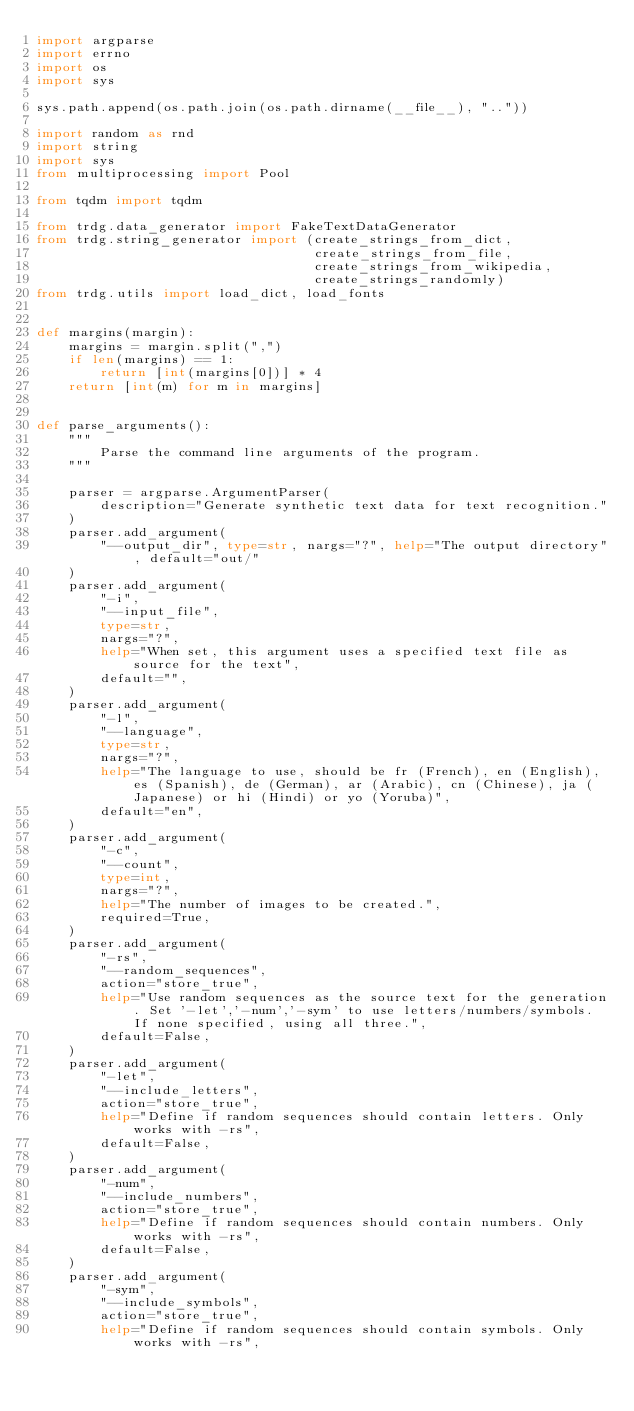Convert code to text. <code><loc_0><loc_0><loc_500><loc_500><_Python_>import argparse
import errno
import os
import sys

sys.path.append(os.path.join(os.path.dirname(__file__), ".."))

import random as rnd
import string
import sys
from multiprocessing import Pool

from tqdm import tqdm

from trdg.data_generator import FakeTextDataGenerator
from trdg.string_generator import (create_strings_from_dict,
                                   create_strings_from_file,
                                   create_strings_from_wikipedia,
                                   create_strings_randomly)
from trdg.utils import load_dict, load_fonts


def margins(margin):
    margins = margin.split(",")
    if len(margins) == 1:
        return [int(margins[0])] * 4
    return [int(m) for m in margins]


def parse_arguments():
    """
        Parse the command line arguments of the program.
    """

    parser = argparse.ArgumentParser(
        description="Generate synthetic text data for text recognition."
    )
    parser.add_argument(
        "--output_dir", type=str, nargs="?", help="The output directory", default="out/"
    )
    parser.add_argument(
        "-i",
        "--input_file",
        type=str,
        nargs="?",
        help="When set, this argument uses a specified text file as source for the text",
        default="",
    )
    parser.add_argument(
        "-l",
        "--language",
        type=str,
        nargs="?",
        help="The language to use, should be fr (French), en (English), es (Spanish), de (German), ar (Arabic), cn (Chinese), ja (Japanese) or hi (Hindi) or yo (Yoruba)",
        default="en",
    )
    parser.add_argument(
        "-c",
        "--count",
        type=int,
        nargs="?",
        help="The number of images to be created.",
        required=True,
    )
    parser.add_argument(
        "-rs",
        "--random_sequences",
        action="store_true",
        help="Use random sequences as the source text for the generation. Set '-let','-num','-sym' to use letters/numbers/symbols. If none specified, using all three.",
        default=False,
    )
    parser.add_argument(
        "-let",
        "--include_letters",
        action="store_true",
        help="Define if random sequences should contain letters. Only works with -rs",
        default=False,
    )
    parser.add_argument(
        "-num",
        "--include_numbers",
        action="store_true",
        help="Define if random sequences should contain numbers. Only works with -rs",
        default=False,
    )
    parser.add_argument(
        "-sym",
        "--include_symbols",
        action="store_true",
        help="Define if random sequences should contain symbols. Only works with -rs",</code> 